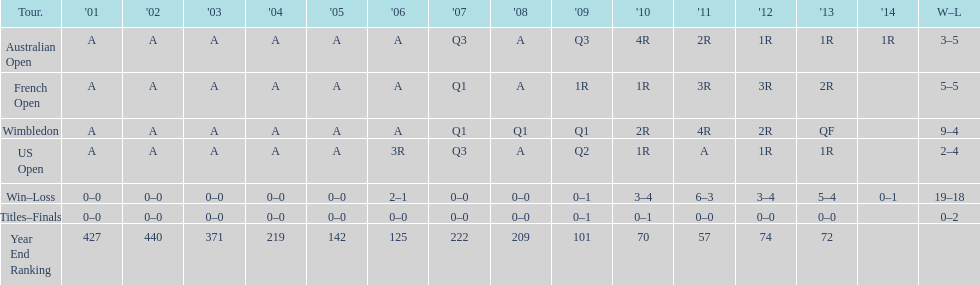Which annual ranking was superior, 2004 or 2011? 2011. 